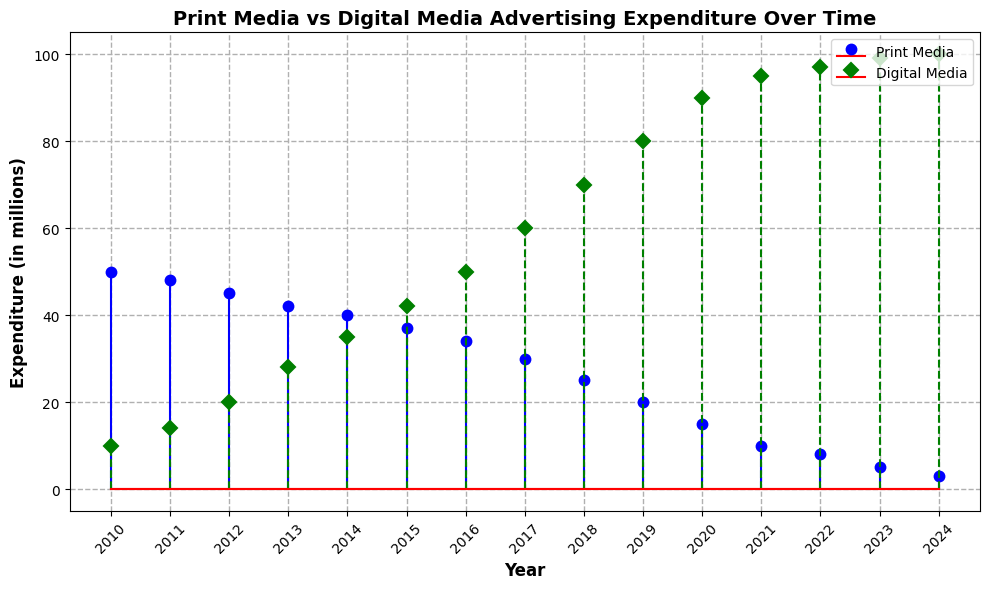What is the general trend of print media expenditure from 2010 to 2024? The expenditures on print media consistently decrease from 50 million in 2010 to 3 million in 2024, showing a clear downward trend.
Answer: Downward trend How does the digital media expenditure in 2020 compare to print media expenditure in 2020? In 2020, digital media expenditure is 90 million, while print media expenditure is 15 million. Thus, digital media expenditure is significantly higher than print media expenditure.
Answer: Digital media expenditure is higher Which year marks the first time digital media expenditure surpasses print media expenditure? By examining the data and the plot, in 2016 digital media expenditure is 50 million and print media expenditure is 34 million, marking the first year digital media surpasses print media.
Answer: 2016 How much does digital media expenditure increase from 2012 to 2013? In 2012, digital media expenditure is 20 million, and in 2013 it is 28 million. The increase is calculated as 28 - 20, which equals 8 million.
Answer: 8 million What is the combined expenditure on both print and digital media in 2022? In 2022, print media expenditure is 8 million and digital media expenditure is 97 million. Their combined expenditure is 8 + 97 = 105 million.
Answer: 105 million What is the visual difference in the markers between print media and digital media? The print media marker is a blue circle, whereas the digital media marker is a green diamond.
Answer: Blue circle for print media, green diamond for digital media Which year shows the highest expenditure on digital media, and what is the amount? The highest expenditure on digital media is in 2024, with an expenditure of 100 million.
Answer: 2024, 100 million Calculate the average annual decrease in print media expenditure from 2010 to 2024. Start by finding the total decrease: 50 million in 2010 to 3 million in 2024 means a decrease of 47 million over 14 years. The average annual decrease is calculated as 47 / 14 = 3.36 million.
Answer: 3.36 million Identify the year with the steepest decline in print media expenditure. From the plot or data, between 2019 and 2020, print media expenditure drops from 20 million to 15 million, the steepest one-year decline of 5 million.
Answer: 2019 to 2020 What is the trend in digital media expenditure from 2010 to 2024? The expenditures on digital media consistently increase from 10 million in 2010 to 100 million in 2024, showing a clear upward trend.
Answer: Upward trend 